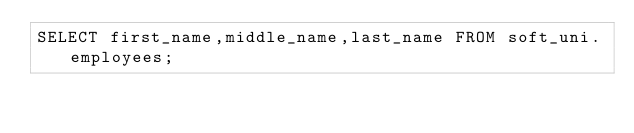<code> <loc_0><loc_0><loc_500><loc_500><_SQL_>SELECT first_name,middle_name,last_name FROM soft_uni.employees;</code> 